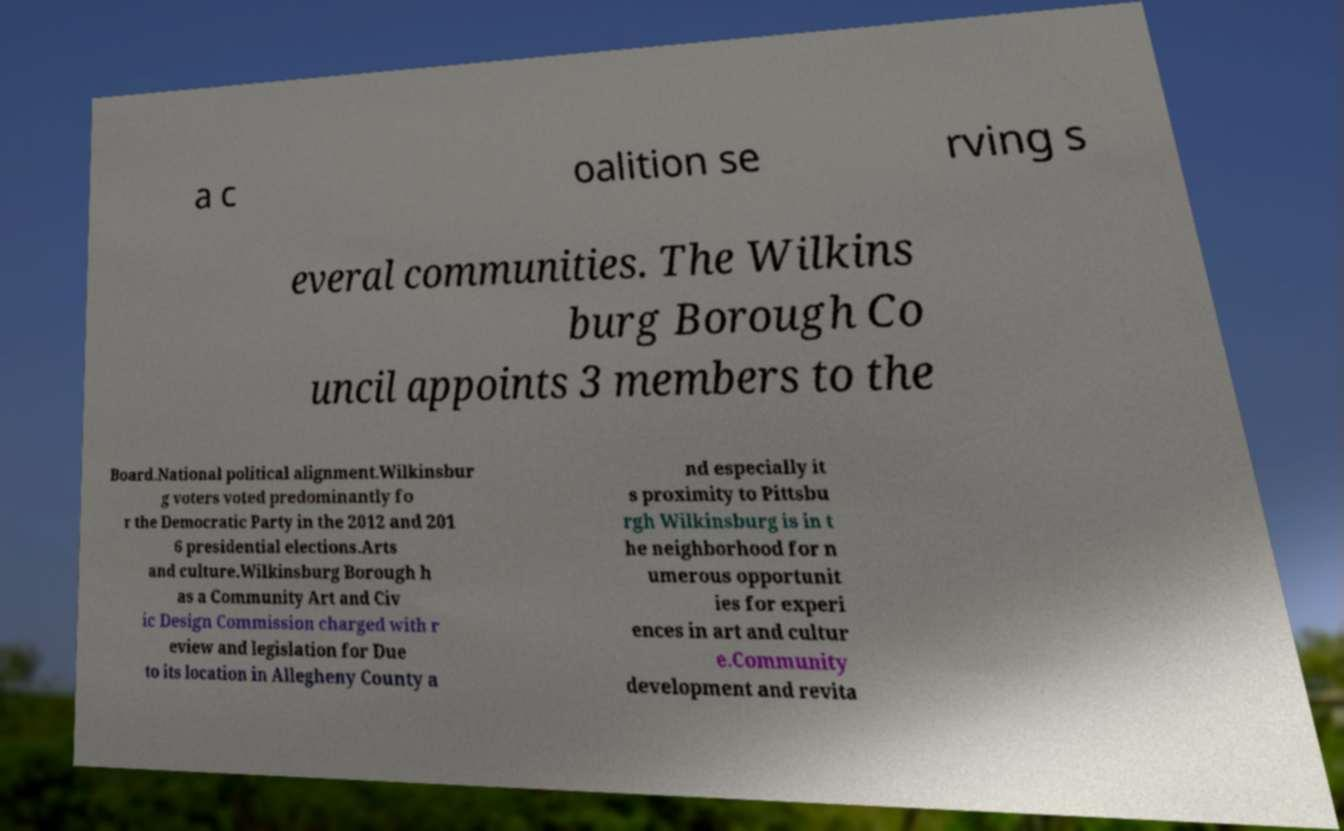I need the written content from this picture converted into text. Can you do that? a c oalition se rving s everal communities. The Wilkins burg Borough Co uncil appoints 3 members to the Board.National political alignment.Wilkinsbur g voters voted predominantly fo r the Democratic Party in the 2012 and 201 6 presidential elections.Arts and culture.Wilkinsburg Borough h as a Community Art and Civ ic Design Commission charged with r eview and legislation for Due to its location in Allegheny County a nd especially it s proximity to Pittsbu rgh Wilkinsburg is in t he neighborhood for n umerous opportunit ies for experi ences in art and cultur e.Community development and revita 